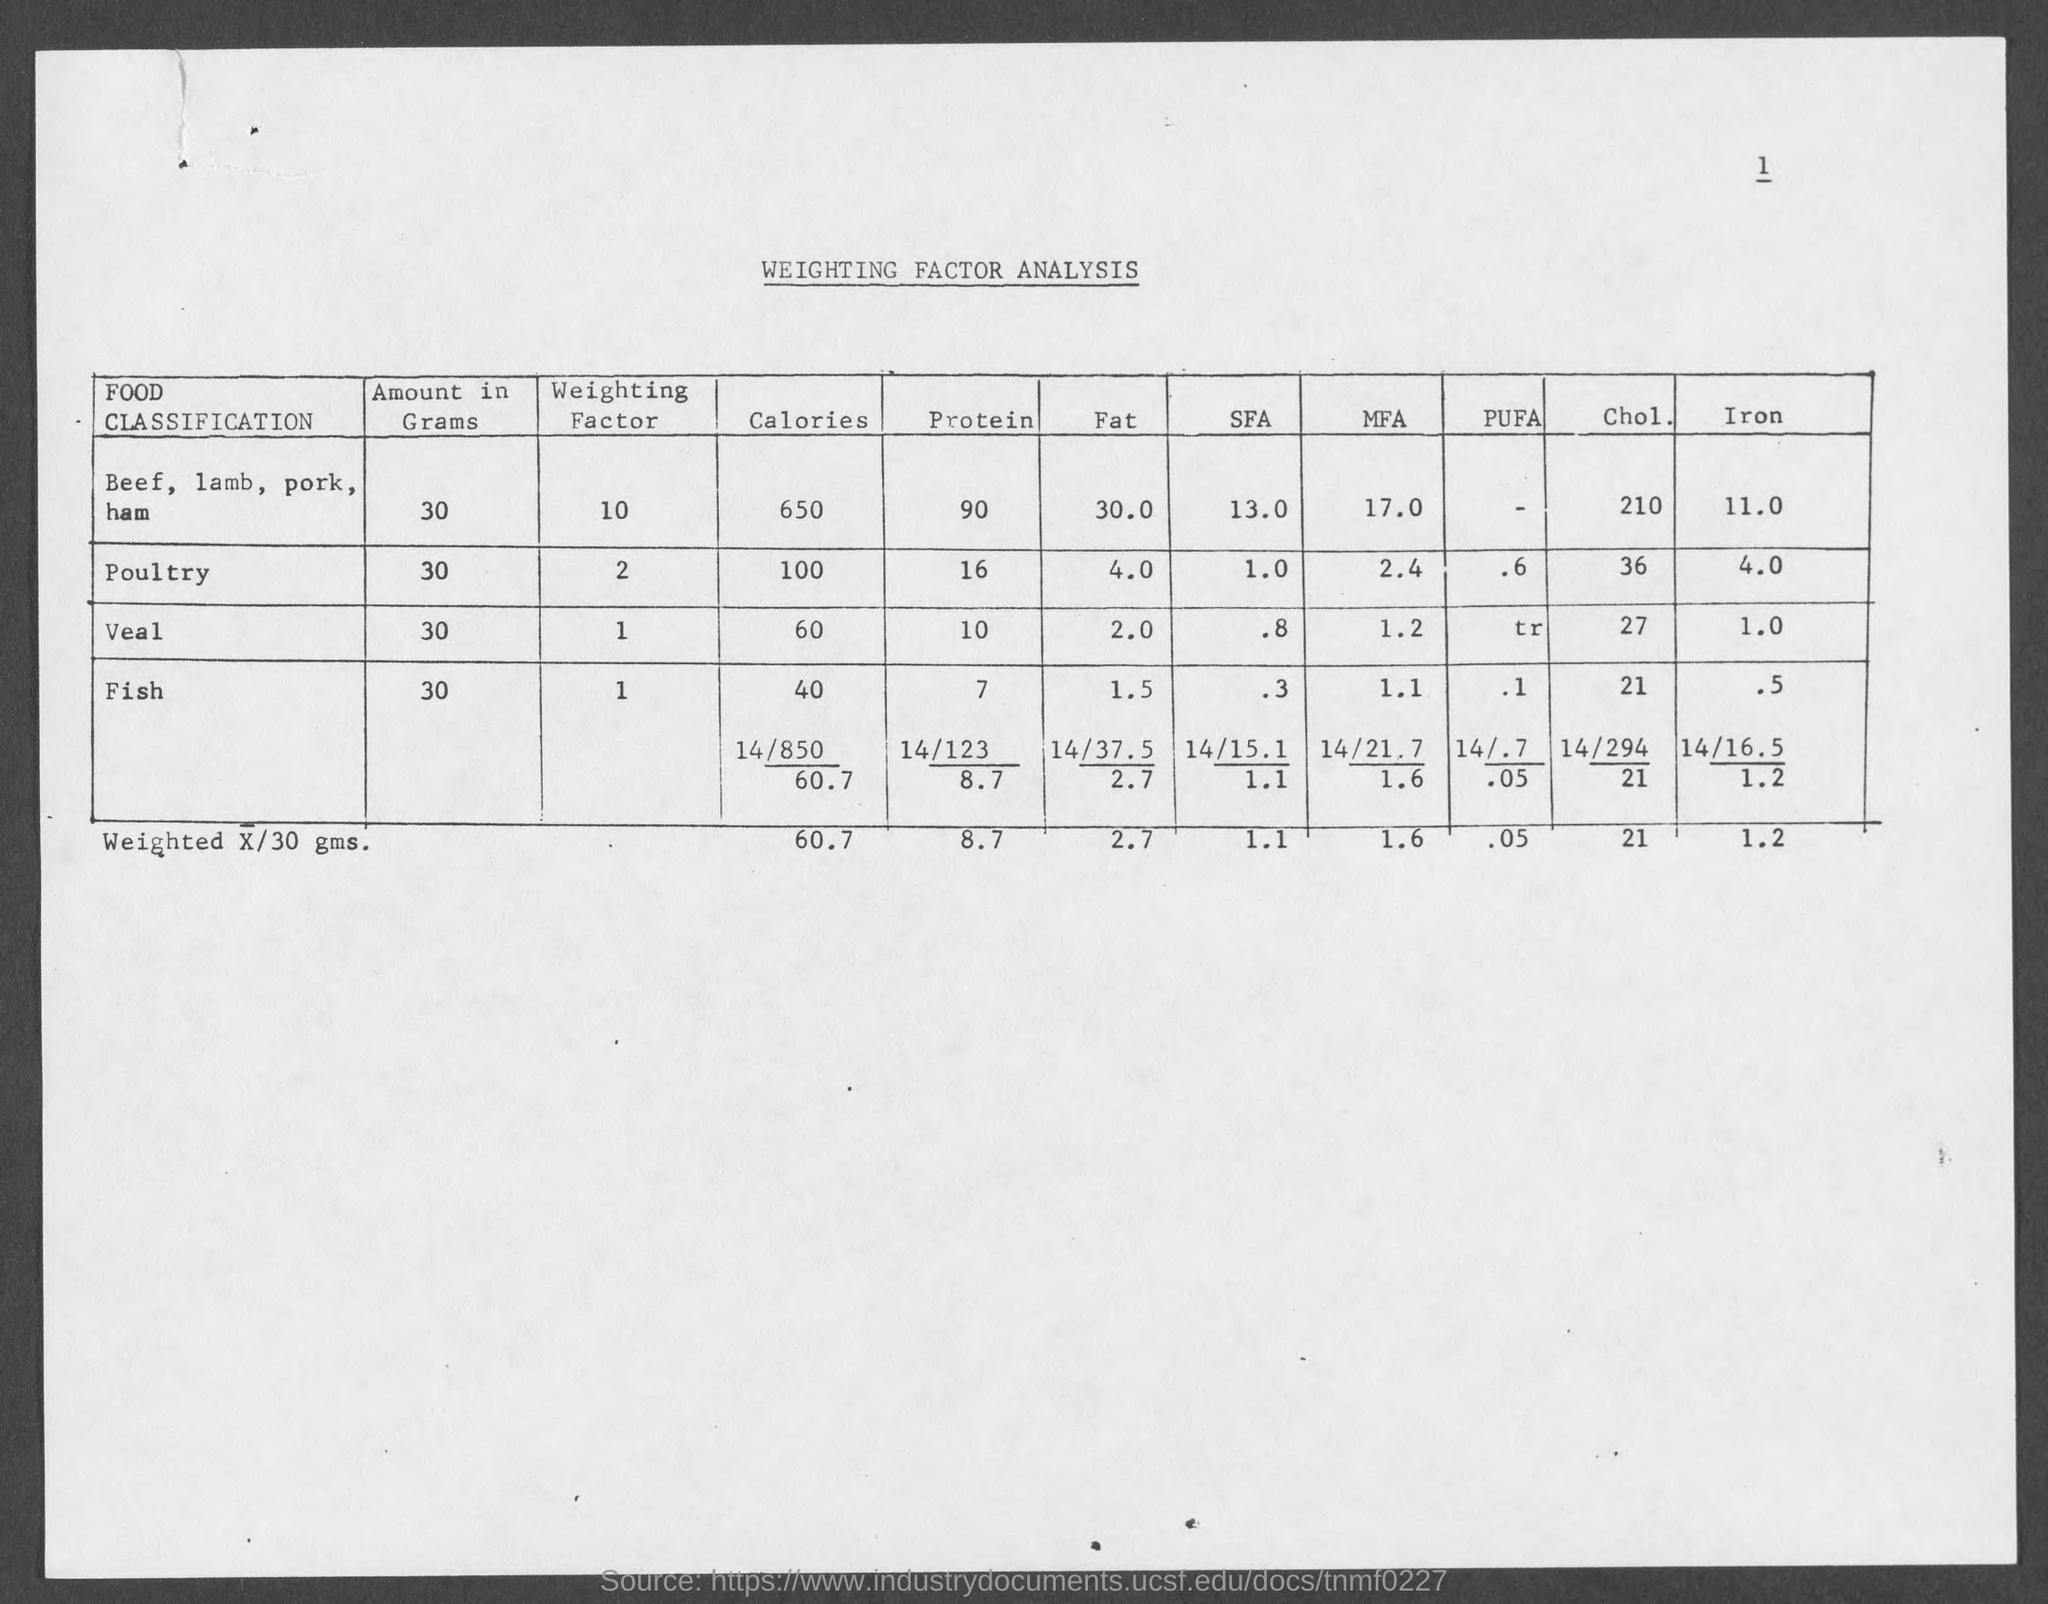Draw attention to some important aspects in this diagram. There are 650 calories in 30 grams of beef. There is approximately 10 grams of protein in 30 grams of veal. There is approximately 60 milligrams of fat in 30 grams of veal. A weighting factor analysis report is provided. 